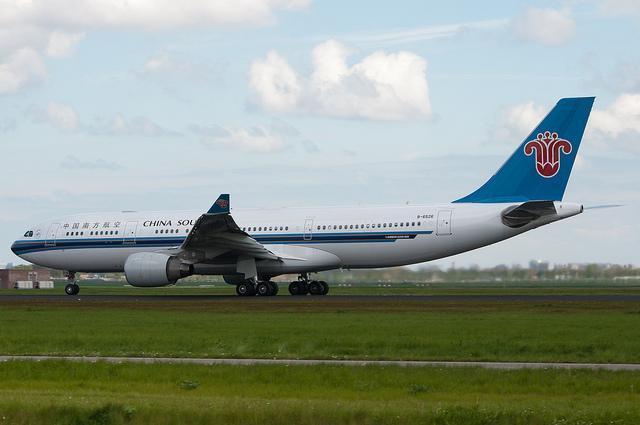How many engines on the plane?
Give a very brief answer. 2. How many cars are in the crosswalk?
Give a very brief answer. 0. 